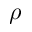Convert formula to latex. <formula><loc_0><loc_0><loc_500><loc_500>\rho</formula> 